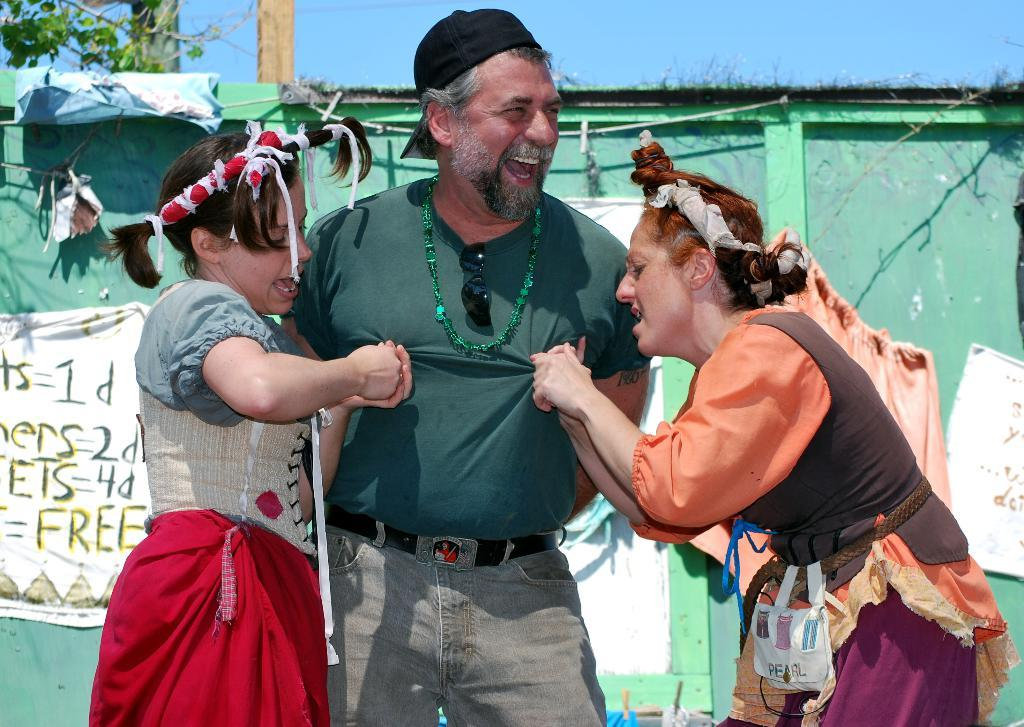Who or what can be seen in the image? There are people in the image. What can be seen in the background of the image? There are posters with text, poles, plants, and the sky visible in the background. Can you describe the posters in the background? The posters in the background have text on them. What type of vegetation is present in the background? There are plants in the background. How many bulbs are hanging from the poles in the image? There are no bulbs present in the image. Can you describe the flock of birds flying in the image? There are no birds or flocks visible in the image. 